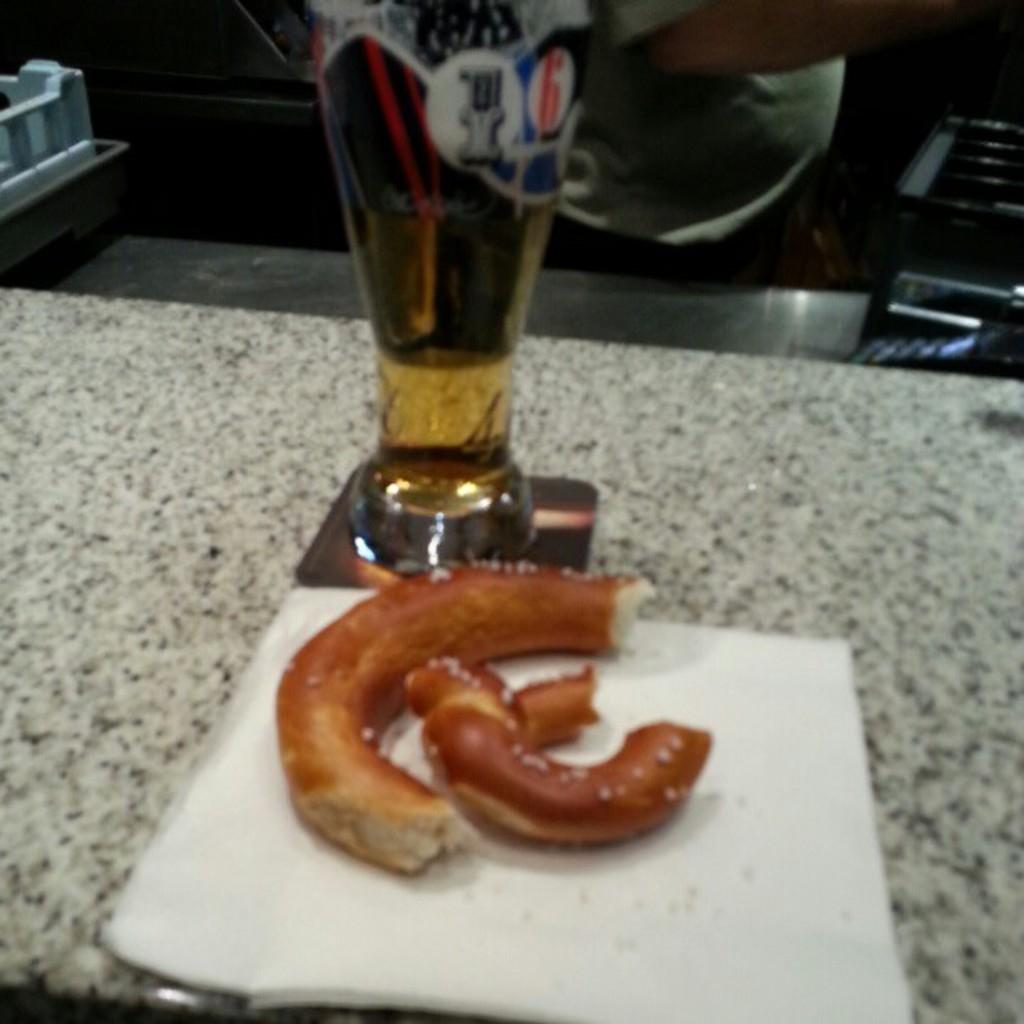What type of food item is in the image? There is a food item in the image, but the specific type is not mentioned in the facts. What can be used for cleaning or wiping in the image? There is a tissue in the image that can be used for cleaning or wiping. What is the food item accompanied by in the image? The food item is accompanied by a glass of drink in the image. Where are the items located in the image? The items are on a counter in the image. What can be seen in the background of the image? There are people and other objects visible in the background of the image. What type of honey is being observed in the image? There is no honey present in the image. Where is the park located in the image? There is no park present in the image. 